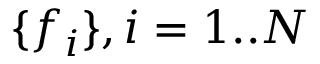Convert formula to latex. <formula><loc_0><loc_0><loc_500><loc_500>\{ f _ { i } \} , i = 1 . . N</formula> 